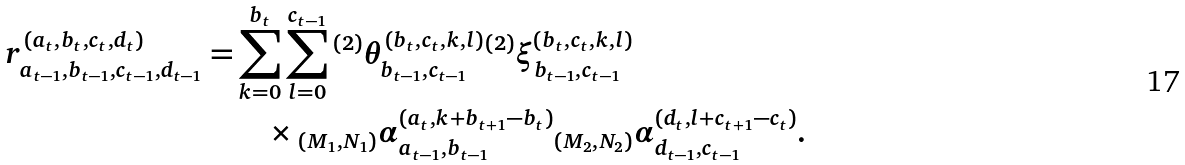<formula> <loc_0><loc_0><loc_500><loc_500>r _ { a _ { t - 1 } , b _ { t - 1 } , c _ { t - 1 } , d _ { t - 1 } } ^ { ( a _ { t } , b _ { t } , c _ { t } , d _ { t } ) } = & \sum _ { k = 0 } ^ { b _ { t } } \sum _ { l = 0 } ^ { c _ { t - 1 } } { ^ { ( 2 ) } } \theta _ { b _ { t - 1 } , c _ { t - 1 } } ^ { ( b _ { t } , c _ { t } , k , l ) } { ^ { ( 2 ) } } \xi _ { b _ { t - 1 } , c _ { t - 1 } } ^ { ( b _ { t } , c _ { t } , k , l ) } \\ & \quad \times { _ { ( M _ { 1 } , N _ { 1 } ) } \alpha _ { a _ { t - 1 } , b _ { t - 1 } } ^ { ( a _ { t } , k + b _ { t + 1 } - b _ { t } ) } } { _ { ( M _ { 2 } , N _ { 2 } ) } \alpha _ { d _ { t - 1 } , c _ { t - 1 } } ^ { ( d _ { t } , l + c _ { t + 1 } - c _ { t } ) } } .</formula> 